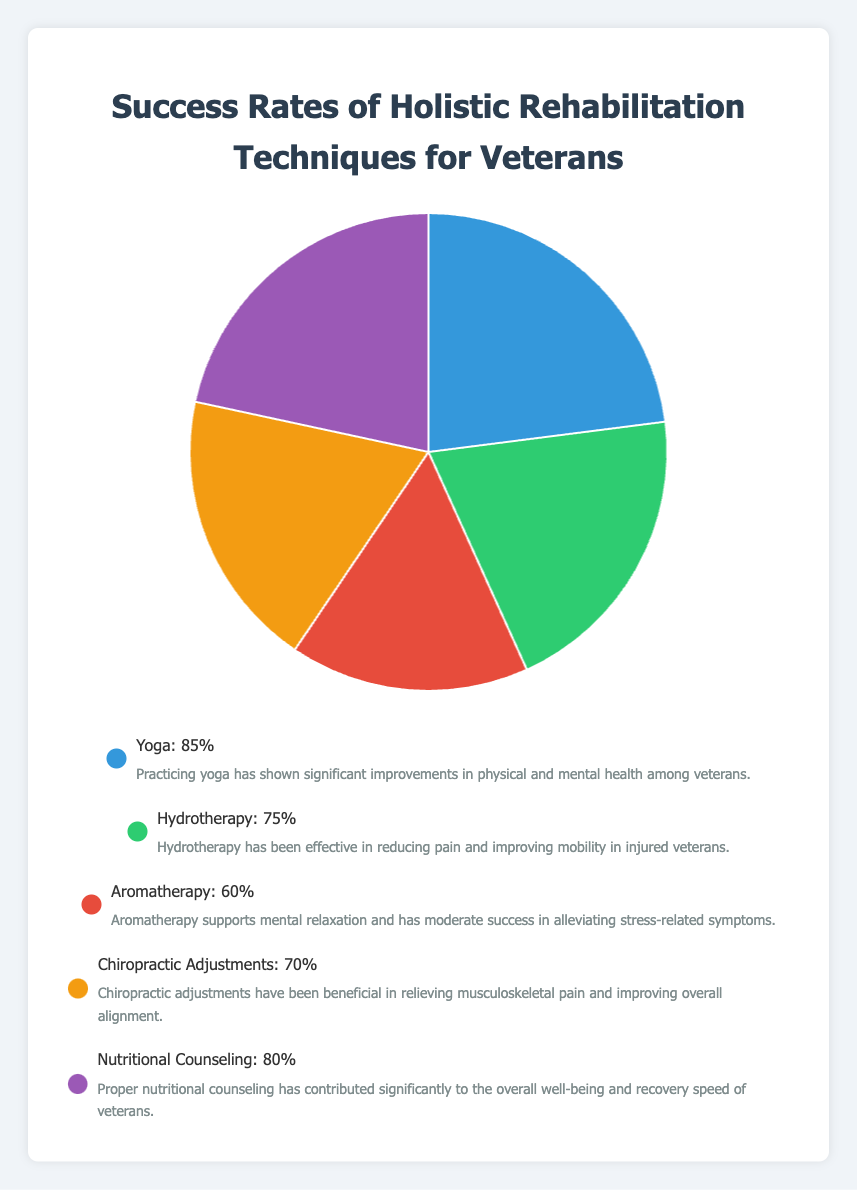Which holistic rehabilitation technique has the highest success rate? Looking at the pie chart, Yoga has the largest segment, indicating it has the highest success rate at 85%.
Answer: Yoga Which technique has a greater success rate: Hydrotherapy or Chiropractic Adjustments? By comparing the segments for Hydrotherapy and Chiropractic Adjustments, Hydrotherapy has a success rate of 75%, while Chiropractic Adjustments has 70%. Hence, Hydrotherapy has a higher success rate.
Answer: Hydrotherapy What is the difference in success rate between Yoga and Aromatherapy? The success rate of Yoga is 85% and Aromatherapy is 60%. Calculating the difference: 85% - 60% = 25%.
Answer: 25% How do the combined success rates of Nutritional Counseling and Yoga compare to the combined success rates of Hydrotherapy and Aromatherapy? Nutritional Counseling has a success rate of 80% and Yoga has 85%; their sum is 80% + 85% = 165%. Hydrotherapy has 75% and Aromatherapy 60%; their sum is 75% + 60% = 135%. Thus, the combined success rates of Nutritional Counseling and Yoga are higher.
Answer: Nutritional Counseling and Yoga What percentage of the pie chart is represented by techniques with success rates below 80%? The techniques with success rates below 80% are Hydrotherapy (75%) and Aromatherapy (60%). Their combined percentage is 75% + 60% = 135%.
Answer: 135% Which holistic rehabilitation technique is represented using the green color? By observing the pie chart's color legend, Hydrotherapy is represented by the green color.
Answer: Hydrotherapy What are the average success rates of all holistic rehabilitation techniques? There are five techniques: Yoga (85%), Hydrotherapy (75%), Aromatherapy (60%), Chiropractic Adjustments (70%), and Nutritional Counseling (80%). Summing these gives 85 + 75 + 60 + 70 + 80 = 370. Dividing by 5 yields an average of 370/5 = 74%.
Answer: 74% If you combine the success rates of Chiropractic Adjustments and any other single technique, which pair yields the smallest combined success rate? Combining Chiropractic Adjustments (70%) with the success rates of Yoga (85%), Hydrotherapy (75%), Aromatherapy (60%), and Nutritional Counseling (80%) gives: 70+85=155, 70+75=145, 70+60=130, and 70+80=150. The smallest combined rate is 130% with Aromatherapy.
Answer: Chiropractic Adjustments and Aromatherapy 